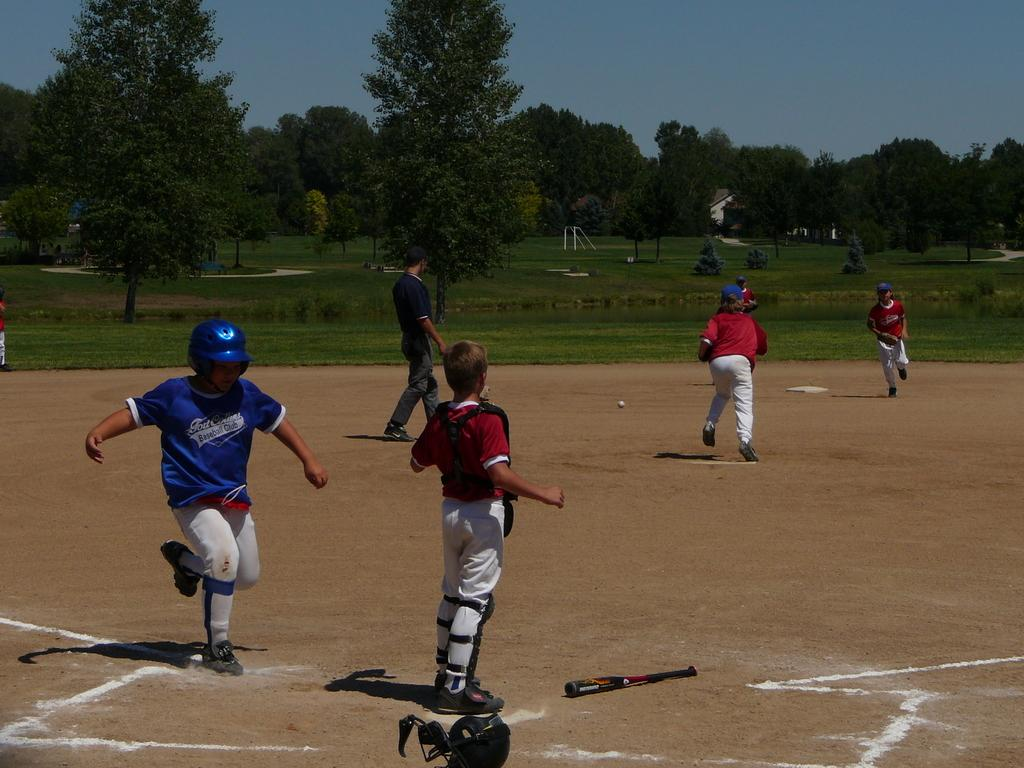<image>
Write a terse but informative summary of the picture. Boys from the Fort Collins Baseball Club compete against opponents during a game. 